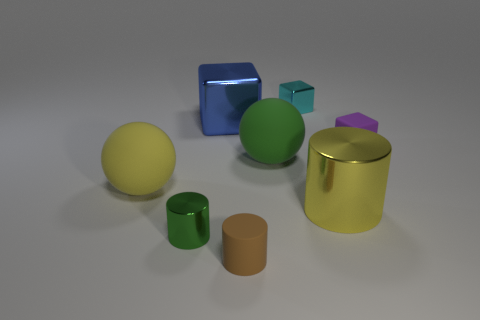There is a yellow cylinder; how many blue metal things are in front of it?
Keep it short and to the point. 0. Do the yellow thing that is on the left side of the tiny metal cylinder and the ball that is on the right side of the yellow matte object have the same material?
Provide a succinct answer. Yes. There is a yellow thing that is to the left of the tiny rubber thing that is in front of the large yellow thing on the left side of the big yellow metal thing; what shape is it?
Your answer should be very brief. Sphere. What is the shape of the purple rubber object?
Your response must be concise. Cube. There is a yellow matte object that is the same size as the green rubber thing; what shape is it?
Give a very brief answer. Sphere. How many other objects are there of the same color as the matte cube?
Give a very brief answer. 0. Do the matte thing to the right of the big cylinder and the tiny metallic object that is to the right of the large blue thing have the same shape?
Your answer should be very brief. Yes. What number of things are large metal objects right of the cyan shiny object or green spheres left of the yellow shiny cylinder?
Provide a short and direct response. 2. How many other things are there of the same material as the large block?
Ensure brevity in your answer.  3. Is the material of the green thing that is in front of the yellow rubber ball the same as the brown thing?
Give a very brief answer. No. 